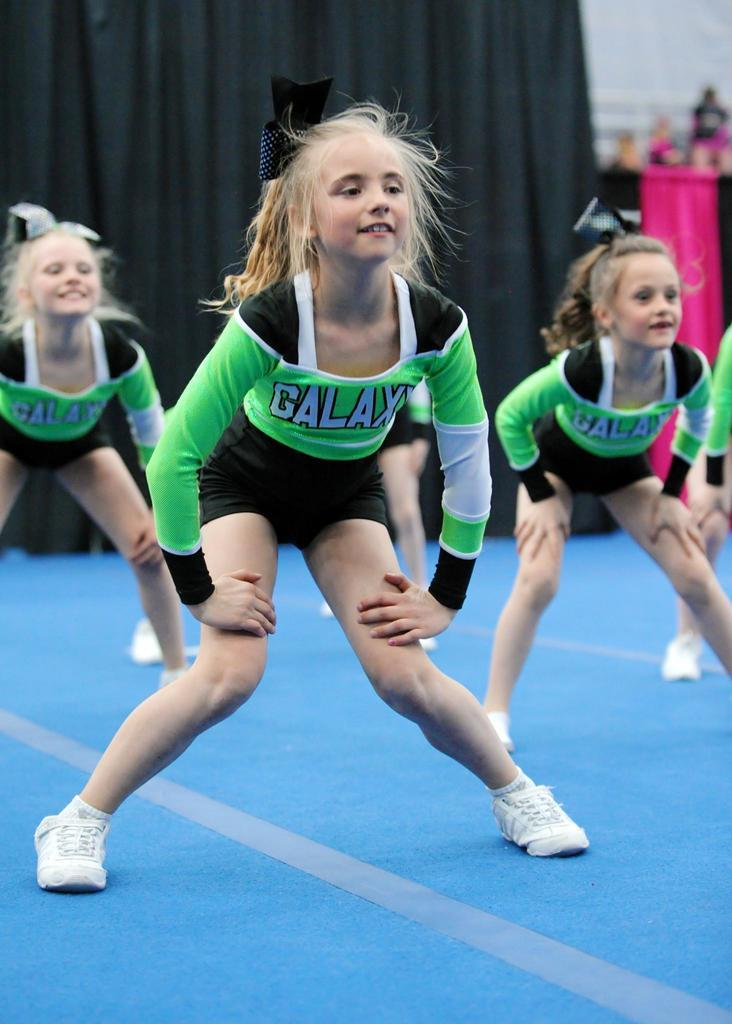Provide a one-sentence caption for the provided image. Girls are in a cheer leading competition and the their team name is the Galaxy. 